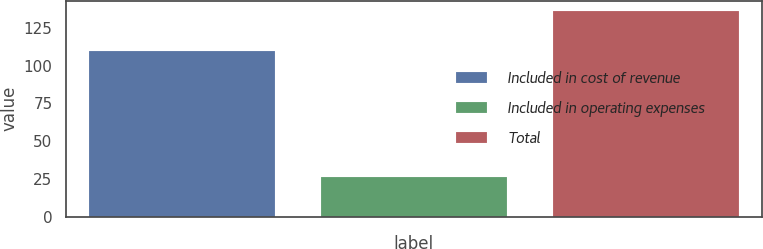Convert chart to OTSL. <chart><loc_0><loc_0><loc_500><loc_500><bar_chart><fcel>Included in cost of revenue<fcel>Included in operating expenses<fcel>Total<nl><fcel>110<fcel>26<fcel>136<nl></chart> 